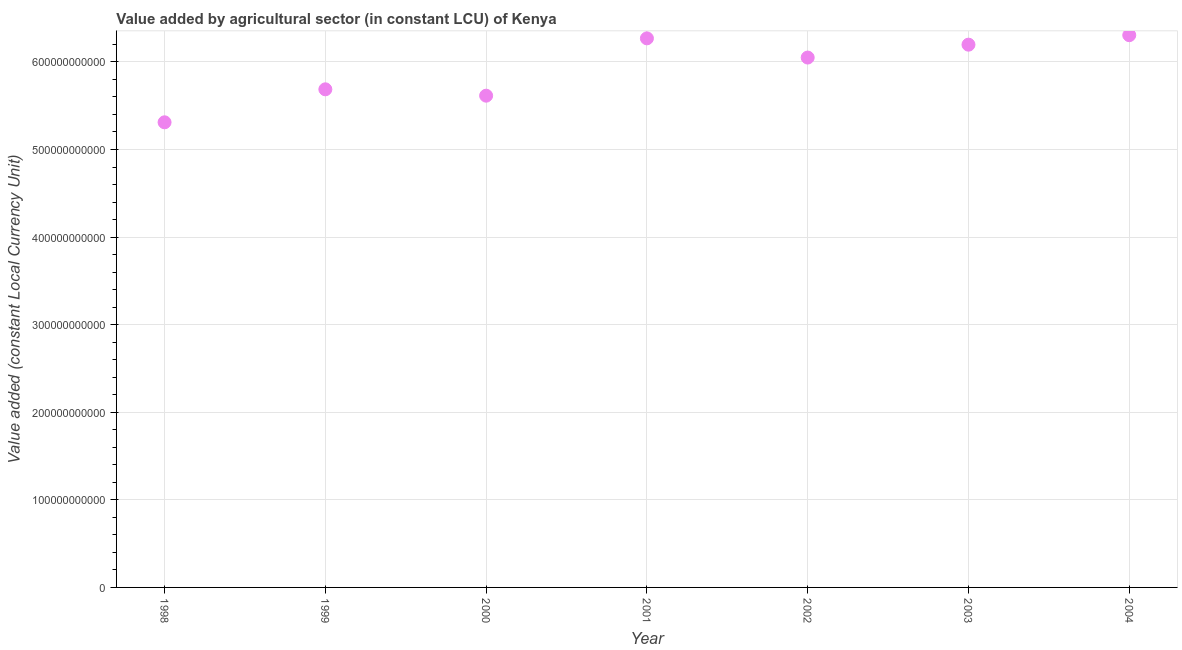What is the value added by agriculture sector in 1998?
Provide a short and direct response. 5.31e+11. Across all years, what is the maximum value added by agriculture sector?
Offer a terse response. 6.31e+11. Across all years, what is the minimum value added by agriculture sector?
Provide a succinct answer. 5.31e+11. In which year was the value added by agriculture sector minimum?
Make the answer very short. 1998. What is the sum of the value added by agriculture sector?
Your response must be concise. 4.14e+12. What is the difference between the value added by agriculture sector in 2002 and 2004?
Your response must be concise. -2.55e+1. What is the average value added by agriculture sector per year?
Offer a terse response. 5.92e+11. What is the median value added by agriculture sector?
Your response must be concise. 6.05e+11. In how many years, is the value added by agriculture sector greater than 580000000000 LCU?
Provide a short and direct response. 4. Do a majority of the years between 2004 and 1998 (inclusive) have value added by agriculture sector greater than 140000000000 LCU?
Ensure brevity in your answer.  Yes. What is the ratio of the value added by agriculture sector in 2000 to that in 2001?
Provide a short and direct response. 0.9. Is the value added by agriculture sector in 2000 less than that in 2001?
Offer a very short reply. Yes. What is the difference between the highest and the second highest value added by agriculture sector?
Offer a terse response. 3.62e+09. What is the difference between the highest and the lowest value added by agriculture sector?
Offer a very short reply. 9.95e+1. In how many years, is the value added by agriculture sector greater than the average value added by agriculture sector taken over all years?
Your answer should be very brief. 4. How many dotlines are there?
Your answer should be compact. 1. How many years are there in the graph?
Offer a very short reply. 7. What is the difference between two consecutive major ticks on the Y-axis?
Your response must be concise. 1.00e+11. Does the graph contain grids?
Ensure brevity in your answer.  Yes. What is the title of the graph?
Ensure brevity in your answer.  Value added by agricultural sector (in constant LCU) of Kenya. What is the label or title of the X-axis?
Provide a short and direct response. Year. What is the label or title of the Y-axis?
Keep it short and to the point. Value added (constant Local Currency Unit). What is the Value added (constant Local Currency Unit) in 1998?
Your response must be concise. 5.31e+11. What is the Value added (constant Local Currency Unit) in 1999?
Offer a terse response. 5.69e+11. What is the Value added (constant Local Currency Unit) in 2000?
Provide a succinct answer. 5.61e+11. What is the Value added (constant Local Currency Unit) in 2001?
Give a very brief answer. 6.27e+11. What is the Value added (constant Local Currency Unit) in 2002?
Your answer should be very brief. 6.05e+11. What is the Value added (constant Local Currency Unit) in 2003?
Ensure brevity in your answer.  6.20e+11. What is the Value added (constant Local Currency Unit) in 2004?
Provide a short and direct response. 6.31e+11. What is the difference between the Value added (constant Local Currency Unit) in 1998 and 1999?
Your answer should be very brief. -3.77e+1. What is the difference between the Value added (constant Local Currency Unit) in 1998 and 2000?
Offer a terse response. -3.04e+1. What is the difference between the Value added (constant Local Currency Unit) in 1998 and 2001?
Offer a terse response. -9.59e+1. What is the difference between the Value added (constant Local Currency Unit) in 1998 and 2002?
Ensure brevity in your answer.  -7.39e+1. What is the difference between the Value added (constant Local Currency Unit) in 1998 and 2003?
Offer a terse response. -8.86e+1. What is the difference between the Value added (constant Local Currency Unit) in 1998 and 2004?
Keep it short and to the point. -9.95e+1. What is the difference between the Value added (constant Local Currency Unit) in 1999 and 2000?
Ensure brevity in your answer.  7.26e+09. What is the difference between the Value added (constant Local Currency Unit) in 1999 and 2001?
Your answer should be very brief. -5.82e+1. What is the difference between the Value added (constant Local Currency Unit) in 1999 and 2002?
Offer a very short reply. -3.63e+1. What is the difference between the Value added (constant Local Currency Unit) in 1999 and 2003?
Provide a short and direct response. -5.10e+1. What is the difference between the Value added (constant Local Currency Unit) in 1999 and 2004?
Keep it short and to the point. -6.18e+1. What is the difference between the Value added (constant Local Currency Unit) in 2000 and 2001?
Your answer should be very brief. -6.55e+1. What is the difference between the Value added (constant Local Currency Unit) in 2000 and 2002?
Ensure brevity in your answer.  -4.35e+1. What is the difference between the Value added (constant Local Currency Unit) in 2000 and 2003?
Provide a succinct answer. -5.82e+1. What is the difference between the Value added (constant Local Currency Unit) in 2000 and 2004?
Give a very brief answer. -6.91e+1. What is the difference between the Value added (constant Local Currency Unit) in 2001 and 2002?
Give a very brief answer. 2.19e+1. What is the difference between the Value added (constant Local Currency Unit) in 2001 and 2003?
Provide a succinct answer. 7.21e+09. What is the difference between the Value added (constant Local Currency Unit) in 2001 and 2004?
Ensure brevity in your answer.  -3.62e+09. What is the difference between the Value added (constant Local Currency Unit) in 2002 and 2003?
Your response must be concise. -1.47e+1. What is the difference between the Value added (constant Local Currency Unit) in 2002 and 2004?
Ensure brevity in your answer.  -2.55e+1. What is the difference between the Value added (constant Local Currency Unit) in 2003 and 2004?
Offer a terse response. -1.08e+1. What is the ratio of the Value added (constant Local Currency Unit) in 1998 to that in 1999?
Provide a short and direct response. 0.93. What is the ratio of the Value added (constant Local Currency Unit) in 1998 to that in 2000?
Ensure brevity in your answer.  0.95. What is the ratio of the Value added (constant Local Currency Unit) in 1998 to that in 2001?
Your answer should be compact. 0.85. What is the ratio of the Value added (constant Local Currency Unit) in 1998 to that in 2002?
Provide a succinct answer. 0.88. What is the ratio of the Value added (constant Local Currency Unit) in 1998 to that in 2003?
Give a very brief answer. 0.86. What is the ratio of the Value added (constant Local Currency Unit) in 1998 to that in 2004?
Make the answer very short. 0.84. What is the ratio of the Value added (constant Local Currency Unit) in 1999 to that in 2001?
Provide a short and direct response. 0.91. What is the ratio of the Value added (constant Local Currency Unit) in 1999 to that in 2003?
Your answer should be very brief. 0.92. What is the ratio of the Value added (constant Local Currency Unit) in 1999 to that in 2004?
Offer a very short reply. 0.9. What is the ratio of the Value added (constant Local Currency Unit) in 2000 to that in 2001?
Your answer should be very brief. 0.9. What is the ratio of the Value added (constant Local Currency Unit) in 2000 to that in 2002?
Make the answer very short. 0.93. What is the ratio of the Value added (constant Local Currency Unit) in 2000 to that in 2003?
Offer a very short reply. 0.91. What is the ratio of the Value added (constant Local Currency Unit) in 2000 to that in 2004?
Give a very brief answer. 0.89. What is the ratio of the Value added (constant Local Currency Unit) in 2001 to that in 2002?
Give a very brief answer. 1.04. What is the ratio of the Value added (constant Local Currency Unit) in 2002 to that in 2003?
Give a very brief answer. 0.98. 